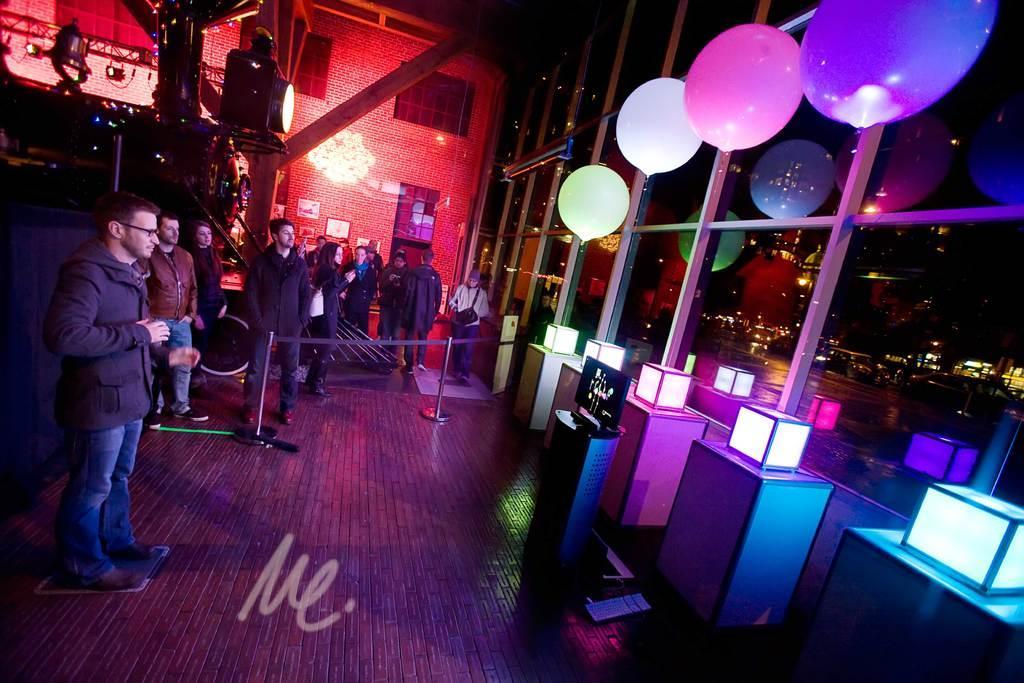How would you summarize this image in a sentence or two? In the background we can see the wall, windows and light rays. We can see the frames on the wall. In this picture we can see the people. On the left side of the picture we can see LED light, bell and some decoration. On the right side of the picture we can see the glass wall decorated with balloons, we can see some boxes placed on the floor. We can see a device kept on the stand. 